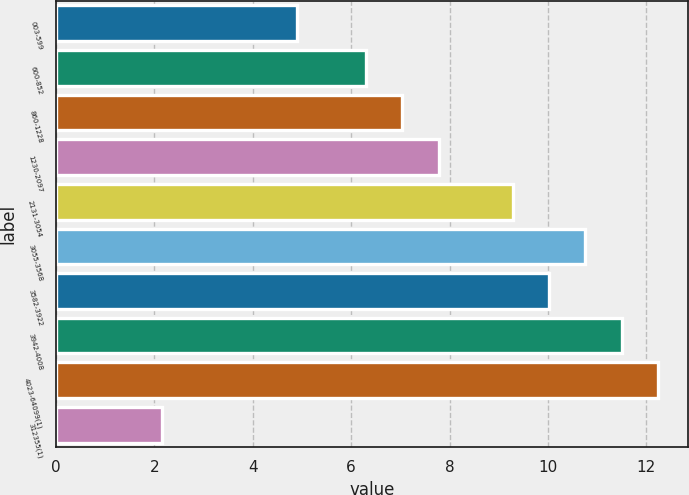Convert chart to OTSL. <chart><loc_0><loc_0><loc_500><loc_500><bar_chart><fcel>003-599<fcel>600-852<fcel>860-1228<fcel>1230-2097<fcel>2131-3054<fcel>3055-3568<fcel>3582-3922<fcel>3942-4008<fcel>4023-64099(1)<fcel>312355(1)<nl><fcel>4.89<fcel>6.3<fcel>7.04<fcel>7.79<fcel>9.28<fcel>10.76<fcel>10.02<fcel>11.5<fcel>12.24<fcel>2.15<nl></chart> 